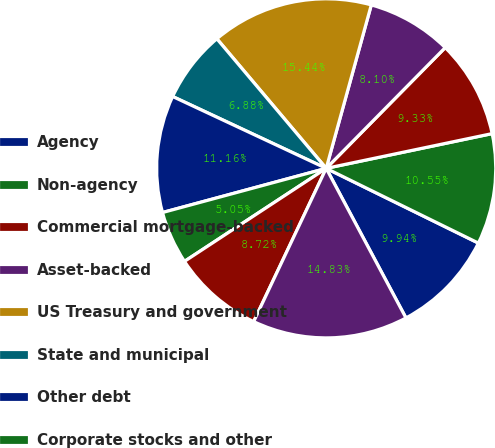<chart> <loc_0><loc_0><loc_500><loc_500><pie_chart><fcel>Agency<fcel>Non-agency<fcel>Commercial mortgage-backed<fcel>Asset-backed<fcel>US Treasury and government<fcel>State and municipal<fcel>Other debt<fcel>Corporate stocks and other<fcel>Total investment securities<fcel>Commercial<nl><fcel>9.94%<fcel>10.55%<fcel>9.33%<fcel>8.1%<fcel>15.44%<fcel>6.88%<fcel>11.16%<fcel>5.05%<fcel>8.72%<fcel>14.83%<nl></chart> 